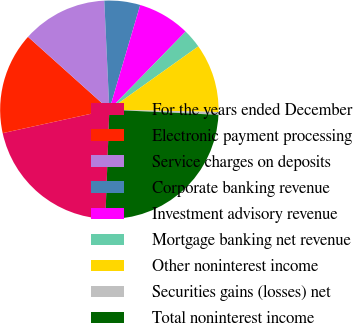Convert chart to OTSL. <chart><loc_0><loc_0><loc_500><loc_500><pie_chart><fcel>For the years ended December<fcel>Electronic payment processing<fcel>Service charges on deposits<fcel>Corporate banking revenue<fcel>Investment advisory revenue<fcel>Mortgage banking net revenue<fcel>Other noninterest income<fcel>Securities gains (losses) net<fcel>Total noninterest income<nl><fcel>20.98%<fcel>15.07%<fcel>12.63%<fcel>5.3%<fcel>7.74%<fcel>2.85%<fcel>10.18%<fcel>0.41%<fcel>24.84%<nl></chart> 